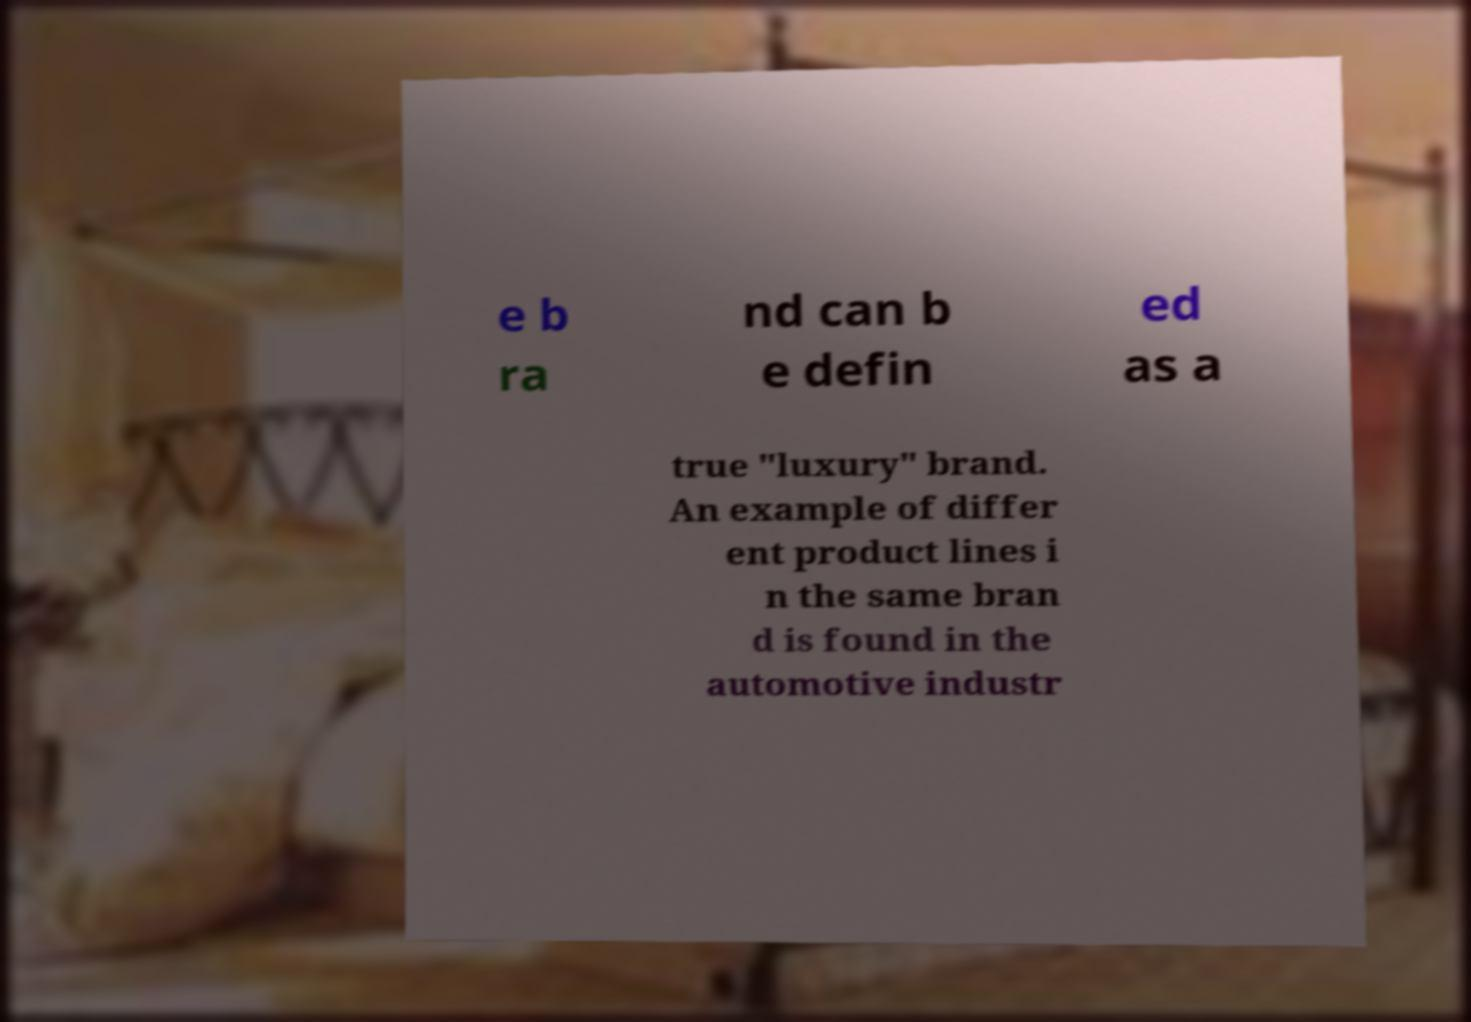Could you assist in decoding the text presented in this image and type it out clearly? e b ra nd can b e defin ed as a true "luxury" brand. An example of differ ent product lines i n the same bran d is found in the automotive industr 